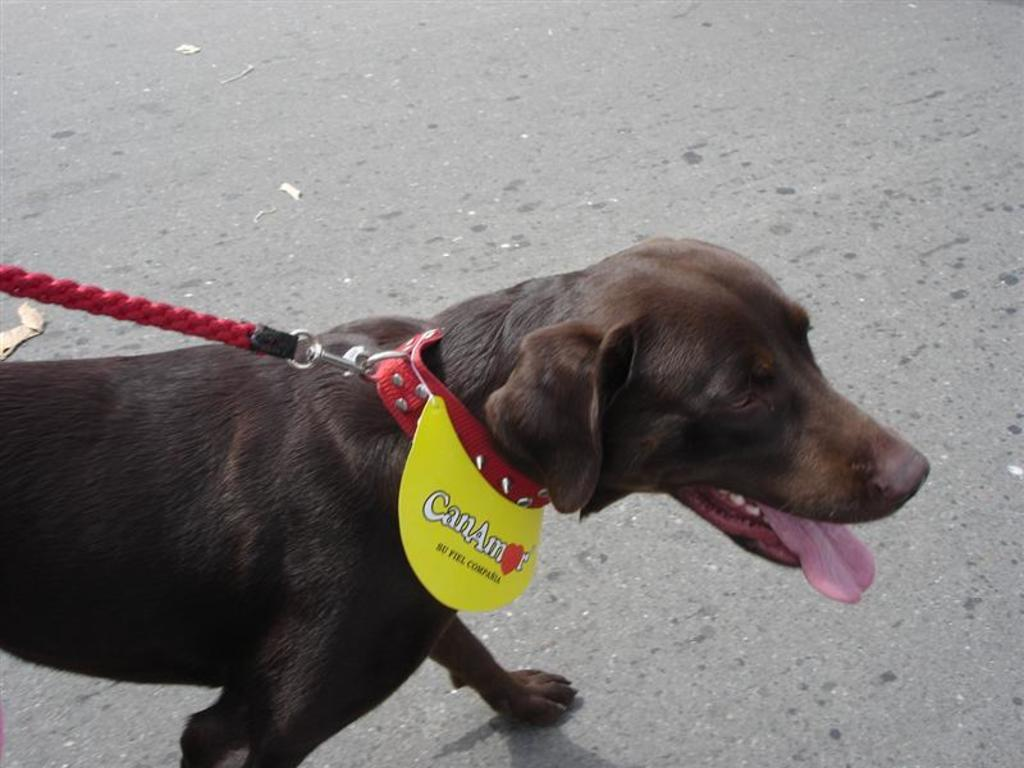What is in the foreground of the image? There is a dog in the foreground of the image. Where is the dog located in the image? The dog is on the road. What time of day was the image taken? The image was taken during the day. Where was the image taken? The image was taken on the road. What type of lumber is the dog carrying in the image? There is no lumber present in the image; the dog is simply on the road. Is the dog driving a vehicle in the image? No, the dog is not driving a vehicle in the image; it is simply on the road. 